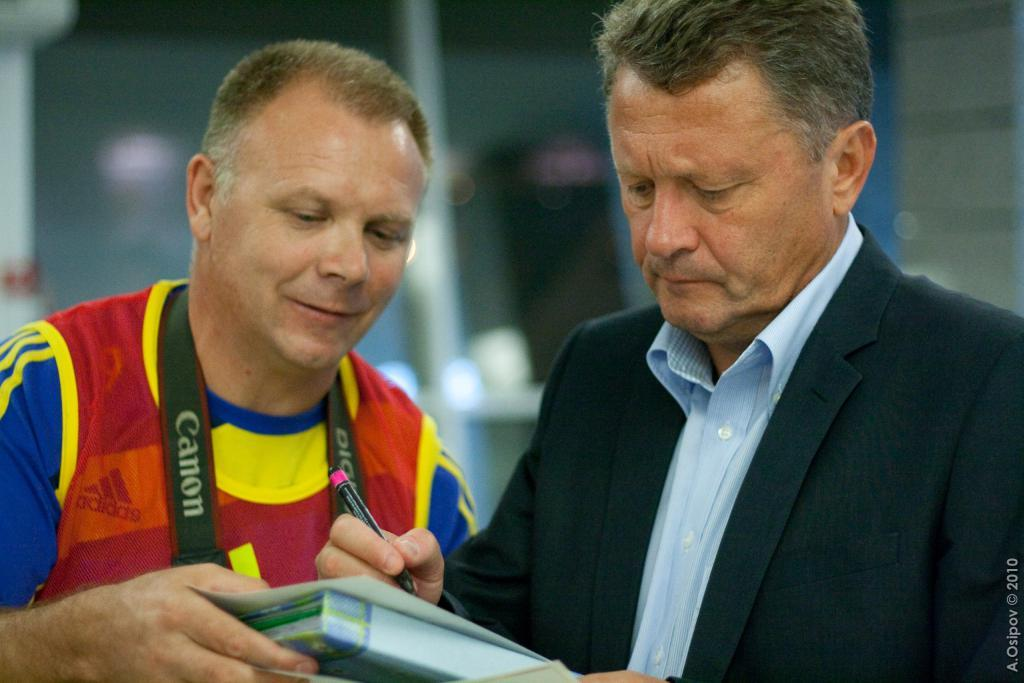How many people are in the image? There are two men in the image. Where are the men positioned in the image? The men are standing in the center of the image. What objects are the men holding? One man is holding a book, and the other man is holding a pen. What is the purpose of the tiger in the image? There is no tiger present in the image. 